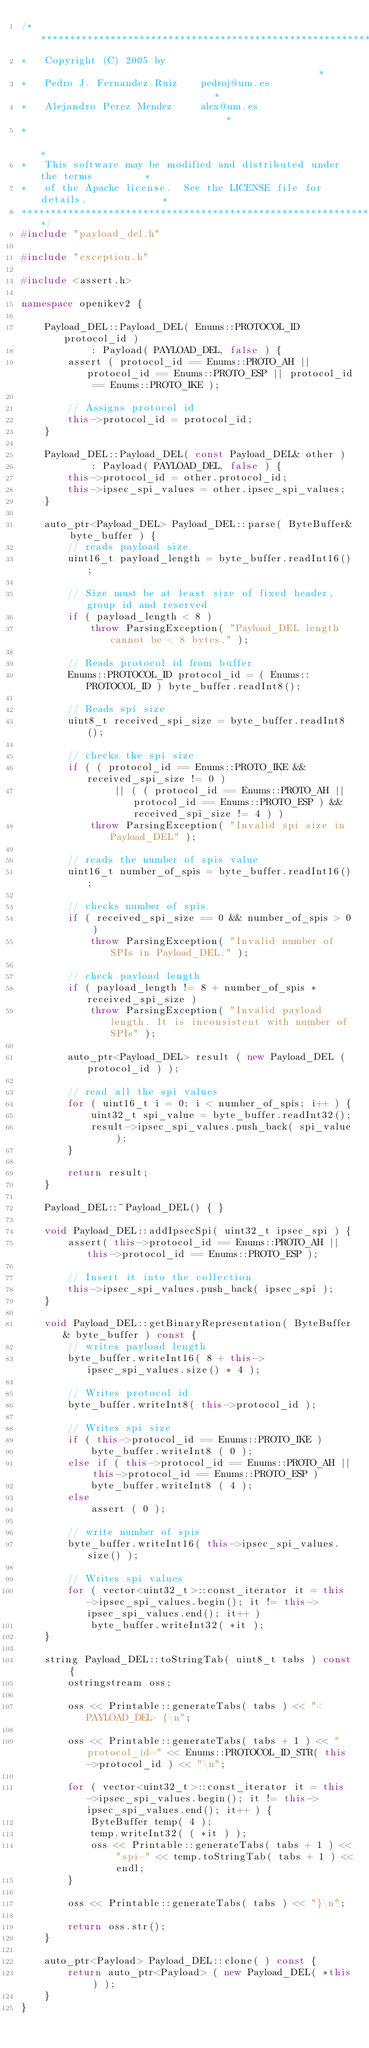<code> <loc_0><loc_0><loc_500><loc_500><_C++_>/***************************************************************************
*   Copyright (C) 2005 by                                                 *
*   Pedro J. Fernandez Ruiz    pedroj@um.es                               *
*   Alejandro Perez Mendez     alex@um.es                                 *
*                                                                         *
*   This software may be modified and distributed under the terms         *
*   of the Apache license.  See the LICENSE file for details.             *
***************************************************************************/
#include "payload_del.h"

#include "exception.h"

#include <assert.h>

namespace openikev2 {

    Payload_DEL::Payload_DEL( Enums::PROTOCOL_ID protocol_id )
            : Payload( PAYLOAD_DEL, false ) {
        assert ( protocol_id == Enums::PROTO_AH || protocol_id == Enums::PROTO_ESP || protocol_id == Enums::PROTO_IKE );

        // Assigns protocol id
        this->protocol_id = protocol_id;
    }

    Payload_DEL::Payload_DEL( const Payload_DEL& other )
            : Payload( PAYLOAD_DEL, false ) {
        this->protocol_id = other.protocol_id;
        this->ipsec_spi_values = other.ipsec_spi_values;
    }

    auto_ptr<Payload_DEL> Payload_DEL::parse( ByteBuffer& byte_buffer ) {
        // reads payload size
        uint16_t payload_length = byte_buffer.readInt16();

        // Size must be at least size of fixed header, group id and reserved
        if ( payload_length < 8 )
            throw ParsingException( "Payload_DEL length cannot be < 8 bytes." );

        // Reads protocol id from buffer
        Enums::PROTOCOL_ID protocol_id = ( Enums::PROTOCOL_ID ) byte_buffer.readInt8();

        // Reads spi size
        uint8_t received_spi_size = byte_buffer.readInt8();

        // checks the spi size
        if ( ( protocol_id == Enums::PROTO_IKE && received_spi_size != 0 )
                || ( ( protocol_id == Enums::PROTO_AH || protocol_id == Enums::PROTO_ESP ) && received_spi_size != 4 ) )
            throw ParsingException( "Invalid spi size in Payload_DEL" );

        // reads the number of spis value
        uint16_t number_of_spis = byte_buffer.readInt16();

        // checks number of spis
        if ( received_spi_size == 0 && number_of_spis > 0 )
            throw ParsingException( "Invalid number of SPIs in Payload_DEL." );

        // check payload length
        if ( payload_length != 8 + number_of_spis * received_spi_size )
            throw ParsingException( "Invalid payload length. It is inconsistent with number of SPIs" );

        auto_ptr<Payload_DEL> result ( new Payload_DEL ( protocol_id ) );

        // read all the spi values
        for ( uint16_t i = 0; i < number_of_spis; i++ ) {
            uint32_t spi_value = byte_buffer.readInt32();
            result->ipsec_spi_values.push_back( spi_value );
        }

        return result;
    }

    Payload_DEL::~Payload_DEL() { }

    void Payload_DEL::addIpsecSpi( uint32_t ipsec_spi ) {
        assert( this->protocol_id == Enums::PROTO_AH || this->protocol_id == Enums::PROTO_ESP );

        // Insert it into the collection
        this->ipsec_spi_values.push_back( ipsec_spi );
    }

    void Payload_DEL::getBinaryRepresentation( ByteBuffer& byte_buffer ) const {
        // writes payload length
        byte_buffer.writeInt16( 8 + this->ipsec_spi_values.size() * 4 );

        // Writes protocol id
        byte_buffer.writeInt8( this->protocol_id );

        // Writes spi size
        if ( this->protocol_id == Enums::PROTO_IKE )
            byte_buffer.writeInt8 ( 0 );
        else if ( this->protocol_id == Enums::PROTO_AH || this->protocol_id == Enums::PROTO_ESP )
            byte_buffer.writeInt8 ( 4 );
        else
            assert ( 0 );

        // write number of spis
        byte_buffer.writeInt16( this->ipsec_spi_values.size() );

        // Writes spi values
        for ( vector<uint32_t>::const_iterator it = this->ipsec_spi_values.begin(); it != this->ipsec_spi_values.end(); it++ )
            byte_buffer.writeInt32( *it );
    }

    string Payload_DEL::toStringTab( uint8_t tabs ) const {
        ostringstream oss;

        oss << Printable::generateTabs( tabs ) << "<PAYLOAD_DEL> {\n";

        oss << Printable::generateTabs( tabs + 1 ) << "protocol_id=" << Enums::PROTOCOL_ID_STR( this->protocol_id ) << "\n";

        for ( vector<uint32_t>::const_iterator it = this->ipsec_spi_values.begin(); it != this->ipsec_spi_values.end(); it++ ) {
            ByteBuffer temp( 4 );
            temp.writeInt32( ( *it ) );
            oss << Printable::generateTabs( tabs + 1 ) << "spi=" << temp.toStringTab( tabs + 1 ) << endl;
        }

        oss << Printable::generateTabs( tabs ) << "}\n";

        return oss.str();
    }

    auto_ptr<Payload> Payload_DEL::clone( ) const {
        return auto_ptr<Payload> ( new Payload_DEL( *this ) );
    }
}

</code> 